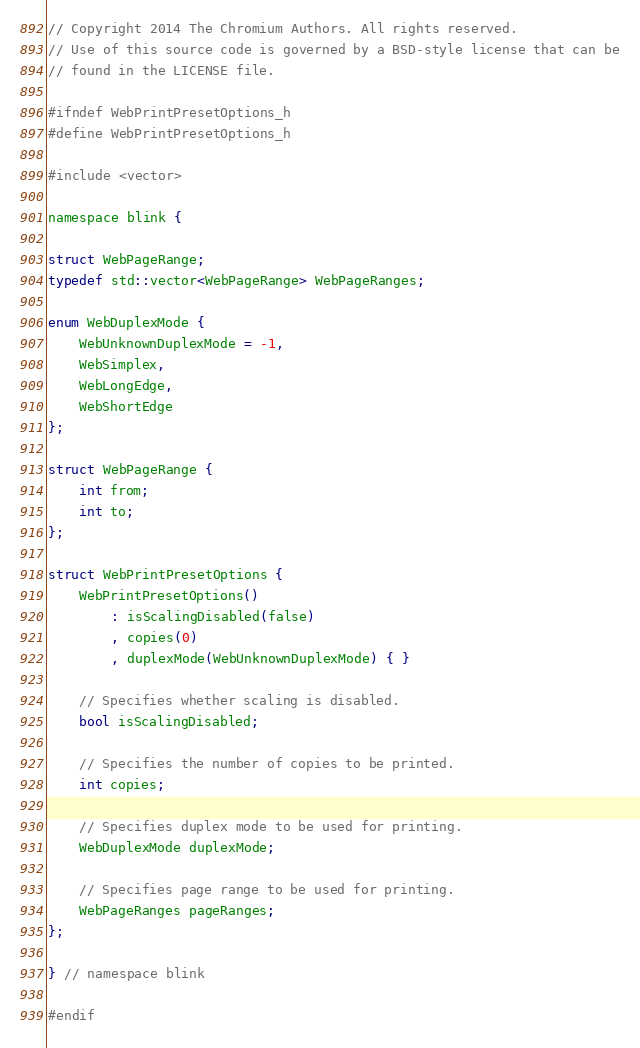Convert code to text. <code><loc_0><loc_0><loc_500><loc_500><_C_>// Copyright 2014 The Chromium Authors. All rights reserved.
// Use of this source code is governed by a BSD-style license that can be
// found in the LICENSE file.

#ifndef WebPrintPresetOptions_h
#define WebPrintPresetOptions_h

#include <vector>

namespace blink {

struct WebPageRange;
typedef std::vector<WebPageRange> WebPageRanges;

enum WebDuplexMode {
    WebUnknownDuplexMode = -1,
    WebSimplex,
    WebLongEdge,
    WebShortEdge
};

struct WebPageRange {
    int from;
    int to;
};

struct WebPrintPresetOptions {
    WebPrintPresetOptions()
        : isScalingDisabled(false)
        , copies(0)
        , duplexMode(WebUnknownDuplexMode) { }

    // Specifies whether scaling is disabled.
    bool isScalingDisabled;

    // Specifies the number of copies to be printed.
    int copies;

    // Specifies duplex mode to be used for printing.
    WebDuplexMode duplexMode;

    // Specifies page range to be used for printing.
    WebPageRanges pageRanges;
};

} // namespace blink

#endif
</code> 